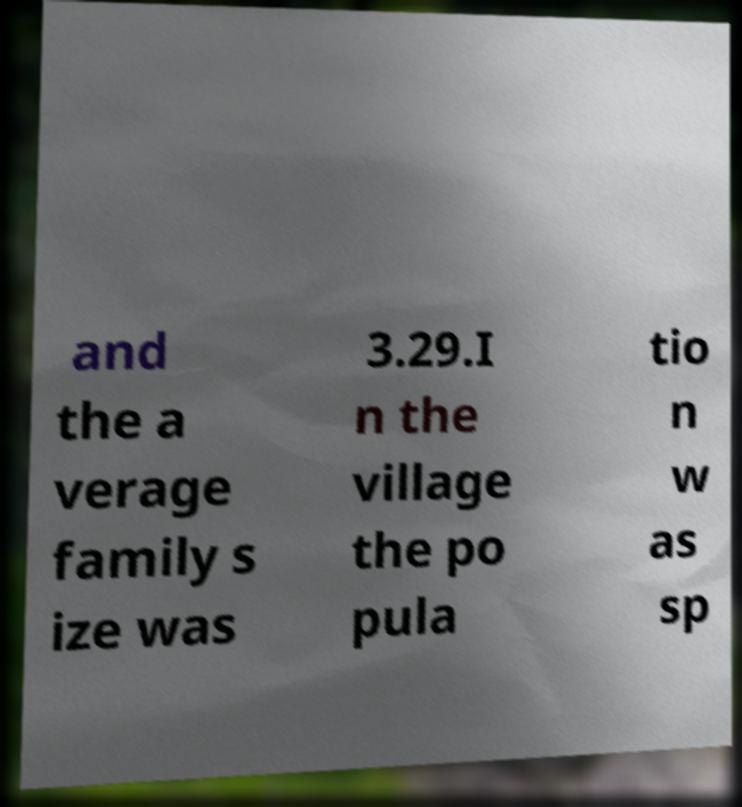Could you extract and type out the text from this image? and the a verage family s ize was 3.29.I n the village the po pula tio n w as sp 